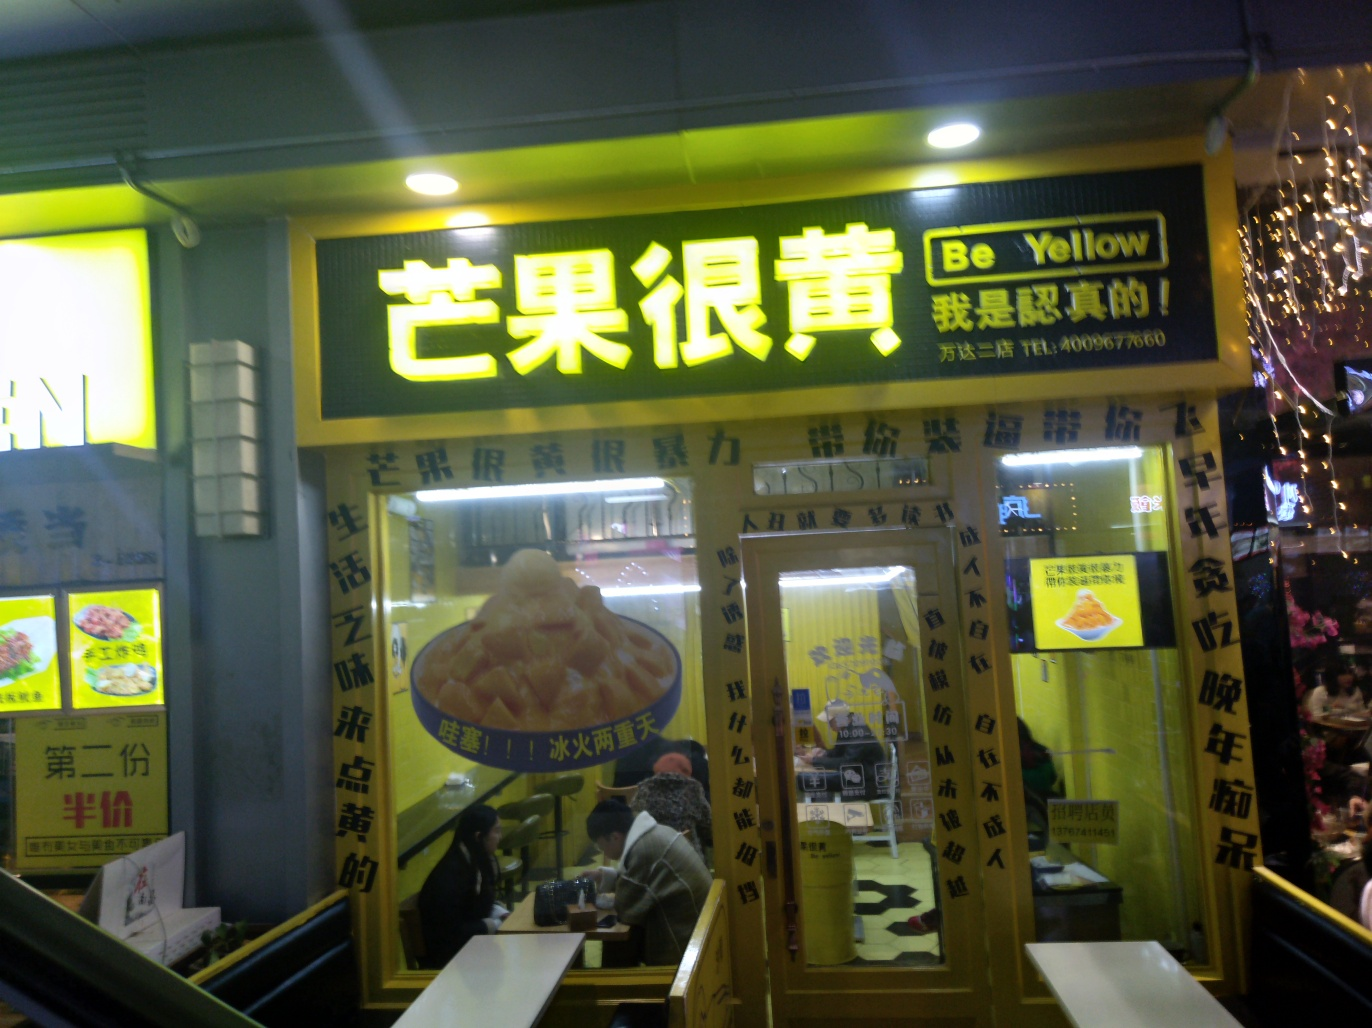What is the quality of this photo?
A. Average
B. Poor
C. Good
Answer with the option's letter from the given choices directly. The quality of the photo can be considered average, as option A suggests. While the main subject, the storefront, is visible, the picture has considerable glare, reflections, and lacks sharpness. The lighting seems uneven and the photo has a slight blur, possibly due to the camera's movement or low light conditions which often result in a decrease of the photo's clarity. 